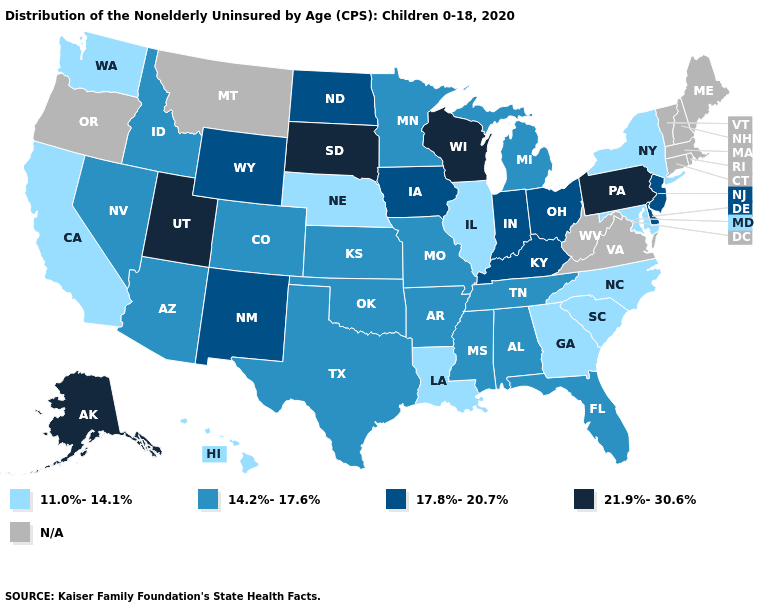Does Utah have the highest value in the West?
Keep it brief. Yes. Name the states that have a value in the range N/A?
Quick response, please. Connecticut, Maine, Massachusetts, Montana, New Hampshire, Oregon, Rhode Island, Vermont, Virginia, West Virginia. Is the legend a continuous bar?
Quick response, please. No. Name the states that have a value in the range N/A?
Write a very short answer. Connecticut, Maine, Massachusetts, Montana, New Hampshire, Oregon, Rhode Island, Vermont, Virginia, West Virginia. What is the value of Alabama?
Quick response, please. 14.2%-17.6%. Does South Dakota have the highest value in the USA?
Be succinct. Yes. Among the states that border Texas , does Arkansas have the highest value?
Quick response, please. No. Name the states that have a value in the range 14.2%-17.6%?
Quick response, please. Alabama, Arizona, Arkansas, Colorado, Florida, Idaho, Kansas, Michigan, Minnesota, Mississippi, Missouri, Nevada, Oklahoma, Tennessee, Texas. What is the lowest value in the USA?
Write a very short answer. 11.0%-14.1%. Name the states that have a value in the range 11.0%-14.1%?
Be succinct. California, Georgia, Hawaii, Illinois, Louisiana, Maryland, Nebraska, New York, North Carolina, South Carolina, Washington. What is the highest value in the USA?
Answer briefly. 21.9%-30.6%. What is the value of Arkansas?
Keep it brief. 14.2%-17.6%. What is the value of Kentucky?
Short answer required. 17.8%-20.7%. What is the lowest value in the Northeast?
Write a very short answer. 11.0%-14.1%. Does Nebraska have the lowest value in the MidWest?
Give a very brief answer. Yes. 